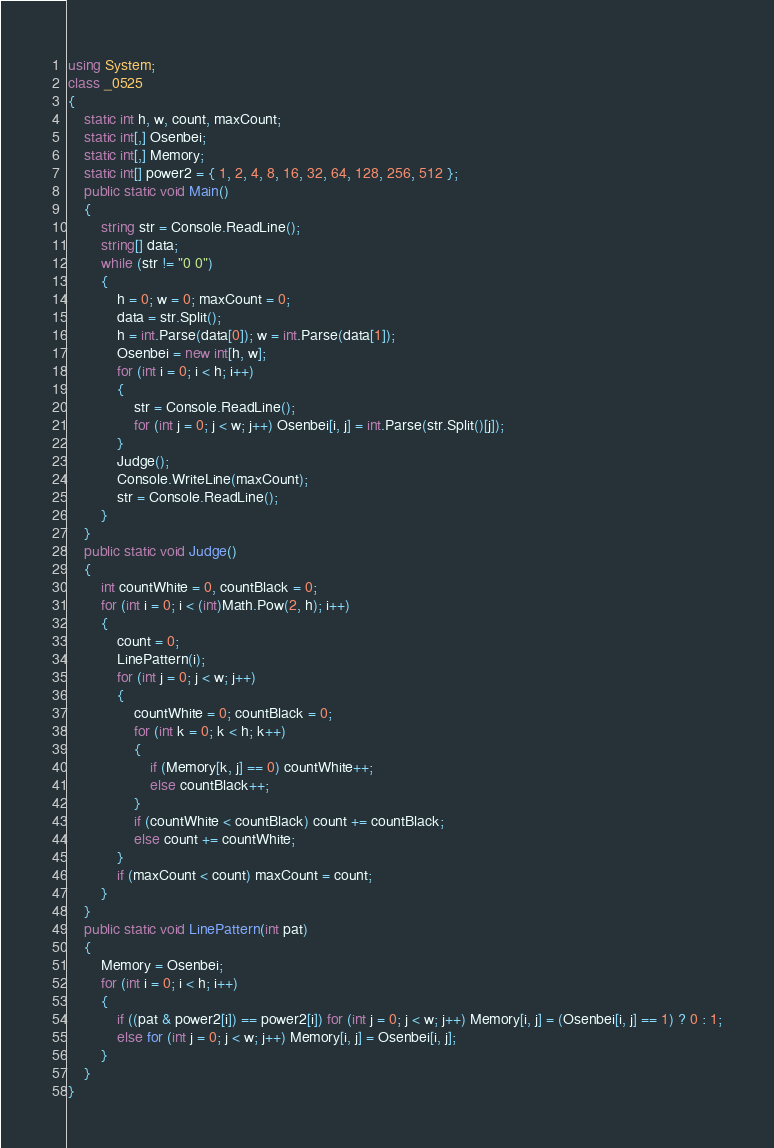<code> <loc_0><loc_0><loc_500><loc_500><_C#_>using System;
class _0525
{
    static int h, w, count, maxCount;
    static int[,] Osenbei;
    static int[,] Memory;
    static int[] power2 = { 1, 2, 4, 8, 16, 32, 64, 128, 256, 512 };
    public static void Main()
    {
        string str = Console.ReadLine();
        string[] data;
        while (str != "0 0")
        {
            h = 0; w = 0; maxCount = 0;
            data = str.Split();
            h = int.Parse(data[0]); w = int.Parse(data[1]);
            Osenbei = new int[h, w];
            for (int i = 0; i < h; i++)
            {
                str = Console.ReadLine();
                for (int j = 0; j < w; j++) Osenbei[i, j] = int.Parse(str.Split()[j]);
            }
            Judge();
            Console.WriteLine(maxCount);
            str = Console.ReadLine();
        }
    }
    public static void Judge()
    {
        int countWhite = 0, countBlack = 0;
        for (int i = 0; i < (int)Math.Pow(2, h); i++)
        {
            count = 0;
            LinePattern(i);
            for (int j = 0; j < w; j++)
            {
                countWhite = 0; countBlack = 0;
                for (int k = 0; k < h; k++)
                {
                    if (Memory[k, j] == 0) countWhite++;
                    else countBlack++;
                }
                if (countWhite < countBlack) count += countBlack;
                else count += countWhite;
            }
            if (maxCount < count) maxCount = count;
        }
    }
    public static void LinePattern(int pat)
    {
        Memory = Osenbei;
        for (int i = 0; i < h; i++)
        {
            if ((pat & power2[i]) == power2[i]) for (int j = 0; j < w; j++) Memory[i, j] = (Osenbei[i, j] == 1) ? 0 : 1;
            else for (int j = 0; j < w; j++) Memory[i, j] = Osenbei[i, j];
        }
    }
}</code> 